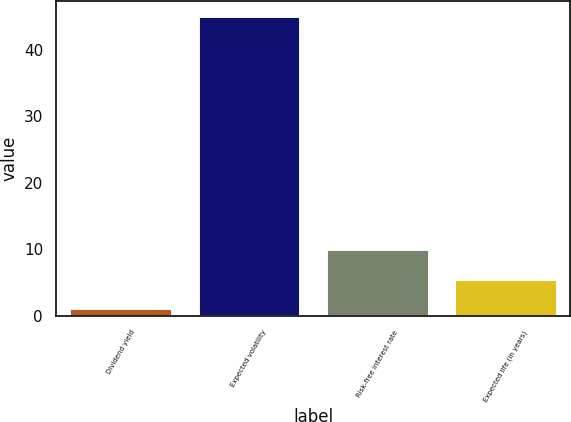<chart> <loc_0><loc_0><loc_500><loc_500><bar_chart><fcel>Dividend yield<fcel>Expected volatility<fcel>Risk-free interest rate<fcel>Expected life (in years)<nl><fcel>1.24<fcel>45<fcel>10<fcel>5.62<nl></chart> 